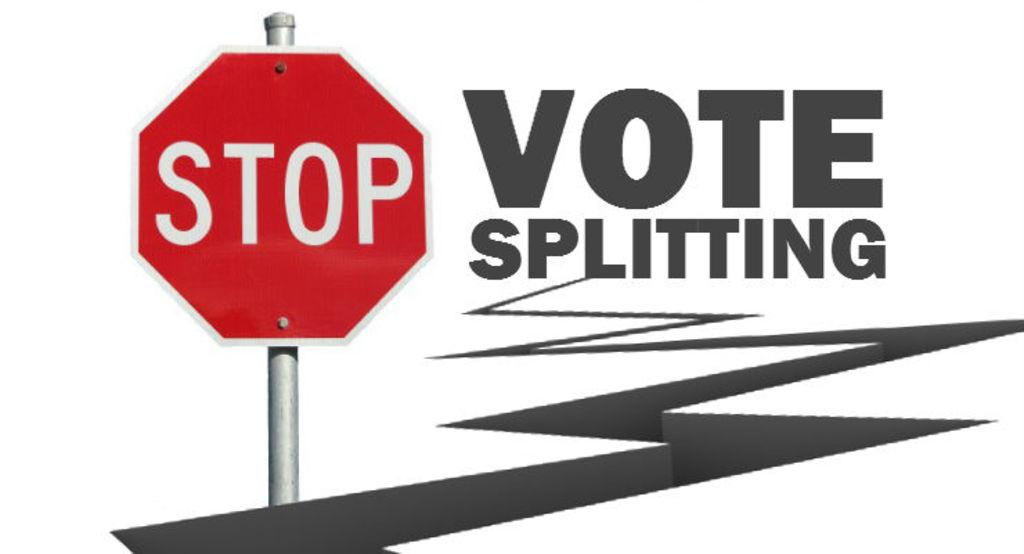<image>
Describe the image concisely. a stop sign that has the words vote splitting next to it 